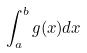Convert formula to latex. <formula><loc_0><loc_0><loc_500><loc_500>\int _ { a } ^ { b } g ( x ) d x</formula> 